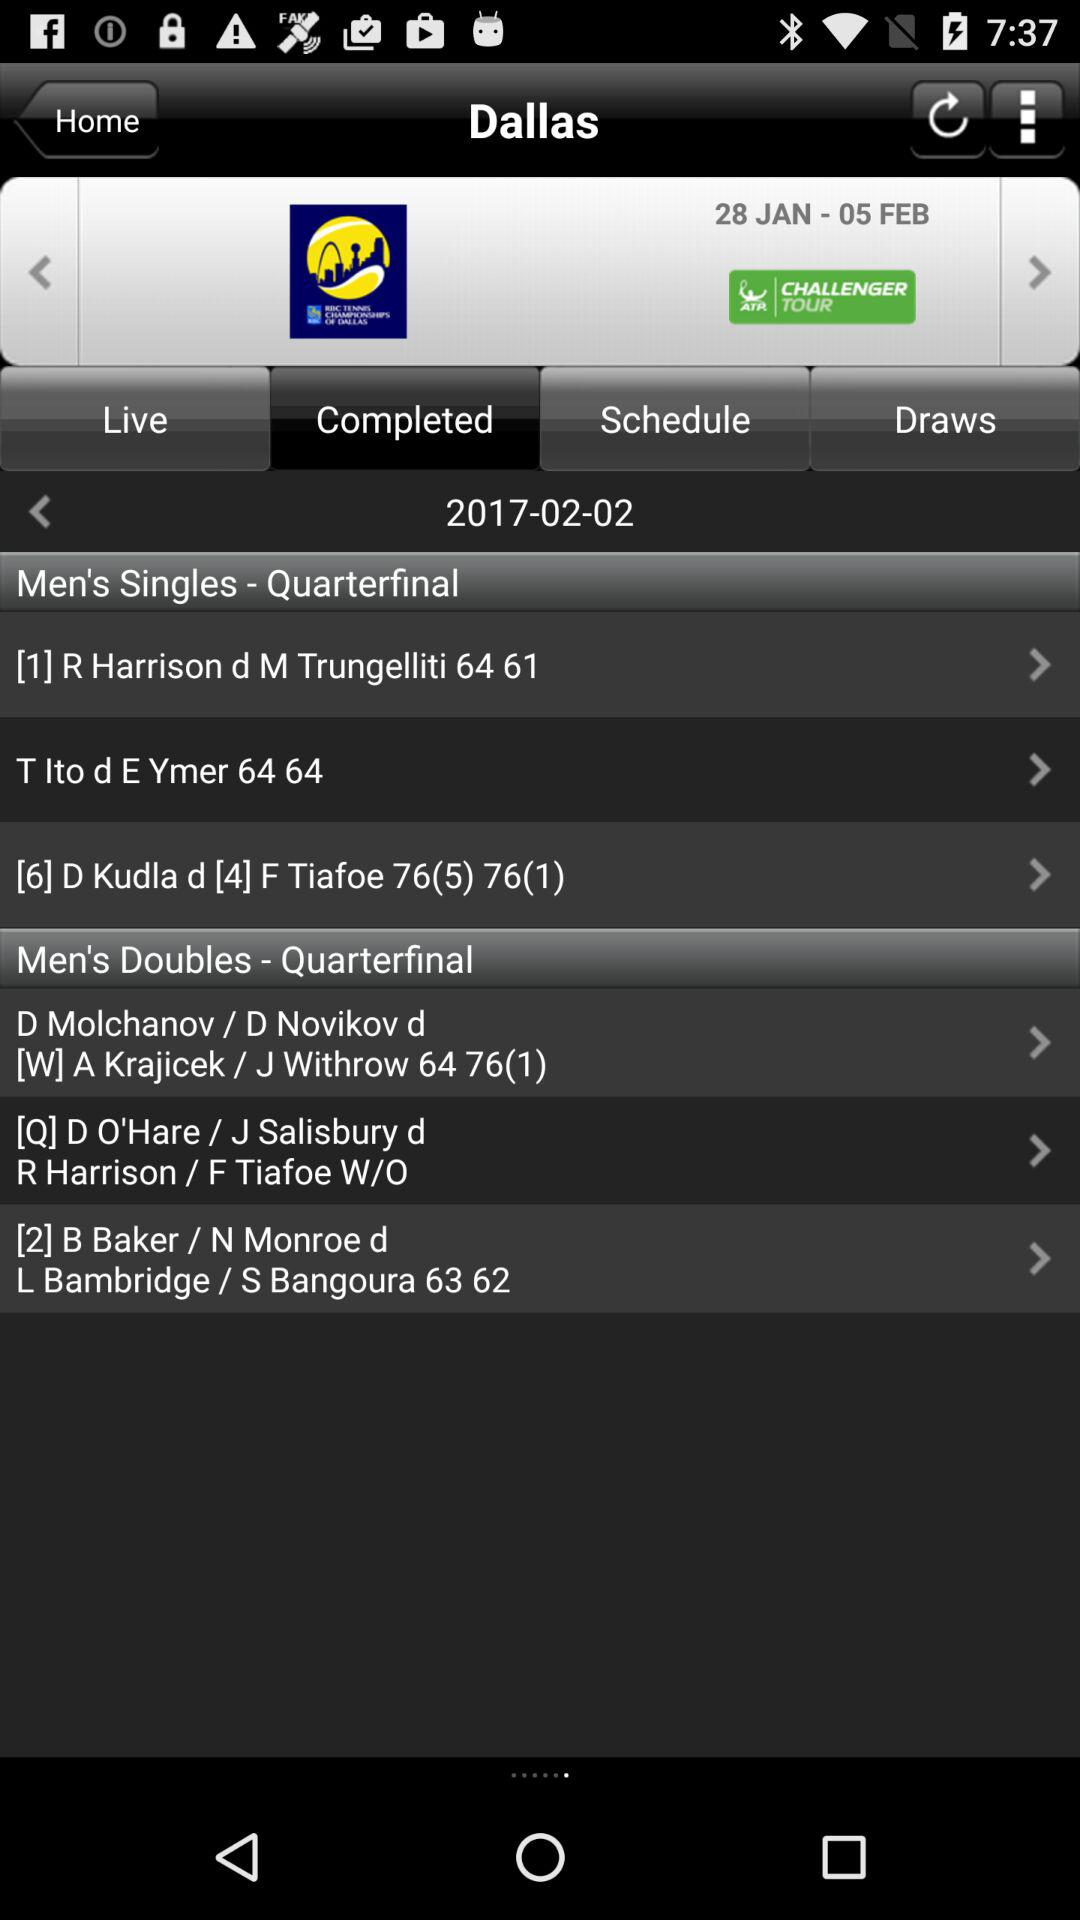Which tab is selected? The selected tab is "Completed". 